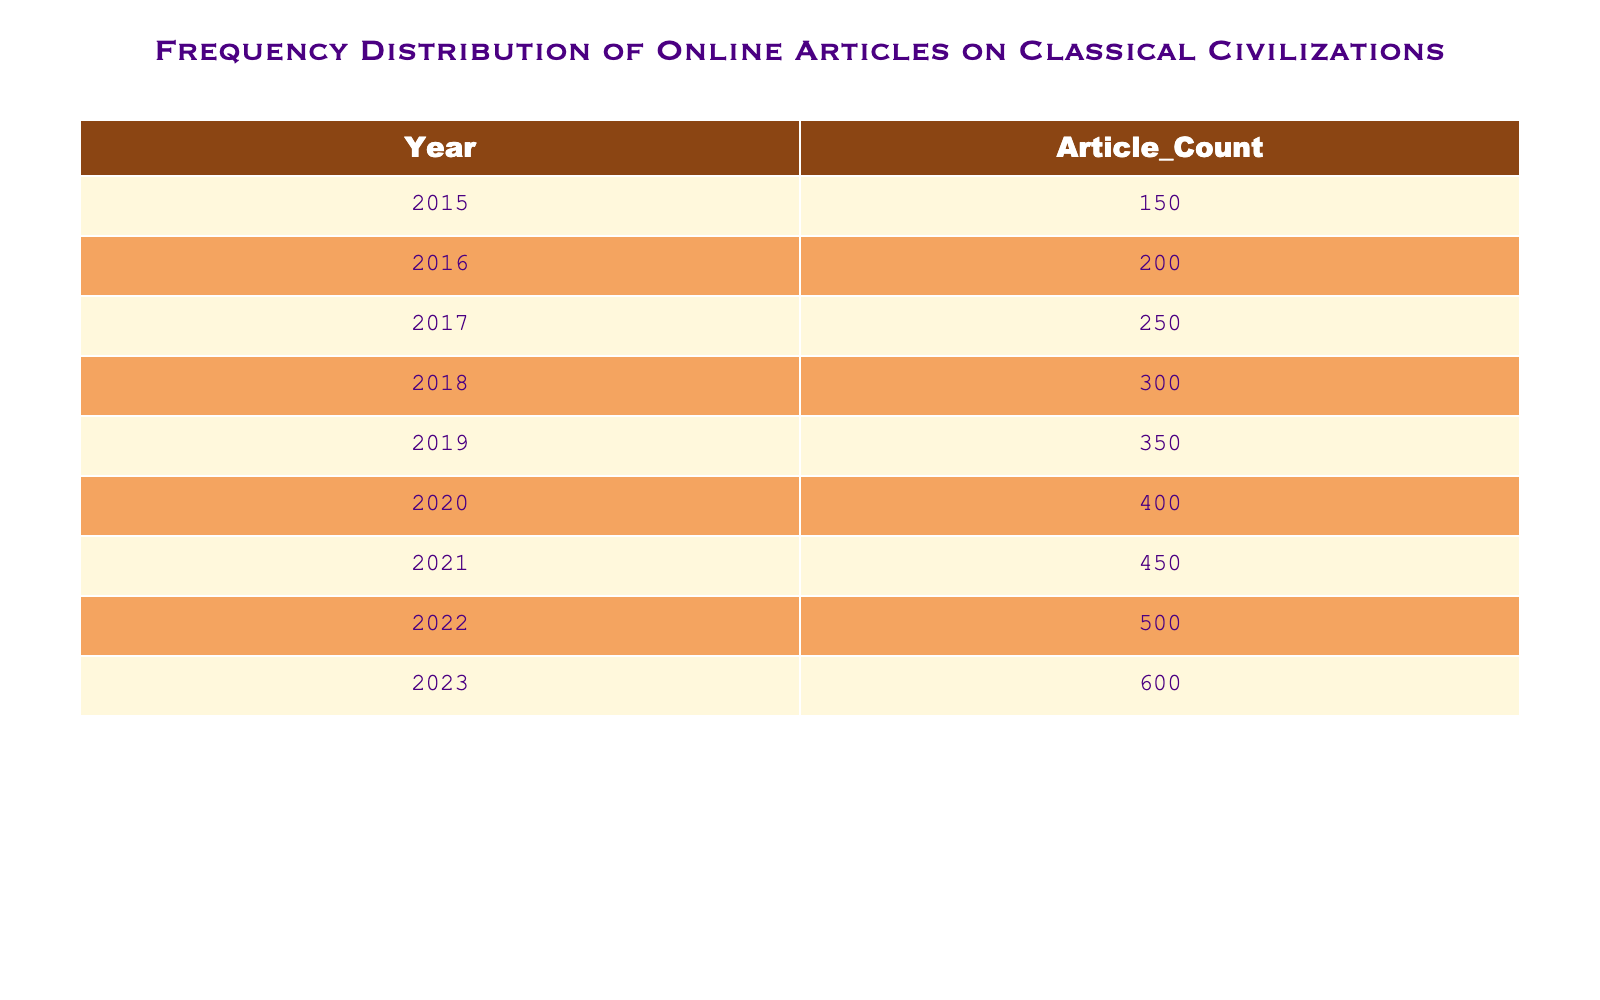What is the article count for the year 2022? The article count for the year 2022 can be directly found in the table under the Year column for 2022, which shows Article_Count as 500.
Answer: 500 Which year saw the highest number of articles published? By examining the Article_Count across all years, the maximum value is 600, which corresponds to the year 2023.
Answer: 2023 What is the total number of articles published from 2015 to 2020? To find the total articles published from 2015 to 2020, we sum the Article_Count values for those years: 150 + 200 + 250 + 300 + 350 + 400 = 1650.
Answer: 1650 In which year was there an increase of 50 articles compared to the previous year? Looking closely at the Article_Count data, the increase of 50 articles occurs from 2021 (450) to 2022 (500).
Answer: 2022 Is it true that more articles were published in 2018 than in 2019? Comparing the Article_Count for 2018 (300) and 2019 (350), it shows that 2019 had more articles. Therefore, the statement is false.
Answer: No What is the average number of articles published per year from 2015 to 2023? To find the average number of articles, first sum all Article_Count values: 150 + 200 + 250 + 300 + 350 + 400 + 450 + 500 + 600 = 3250. There are 9 years in total, so the average is 3250 / 9 = approximately 361.11.
Answer: 361.11 How many articles were published in the year 2016 and how does it compare to 2020? The article count for 2016 is 200 while for 2020 it is 400. The difference between 400 and 200 is 200, indicating that 2020 had 200 articles more than 2016.
Answer: 200 more Which year had the least number of published articles? By examining the Article_Count of every year, 2015 has the least number of articles published with a count of 150.
Answer: 150 How many more articles were published in 2023 than in 2015? The difference in Article_Counts between 2023 (600) and 2015 (150) is calculated as 600 - 150 = 450, which shows that 450 more articles were published in 2023 compared to 2015.
Answer: 450 more 